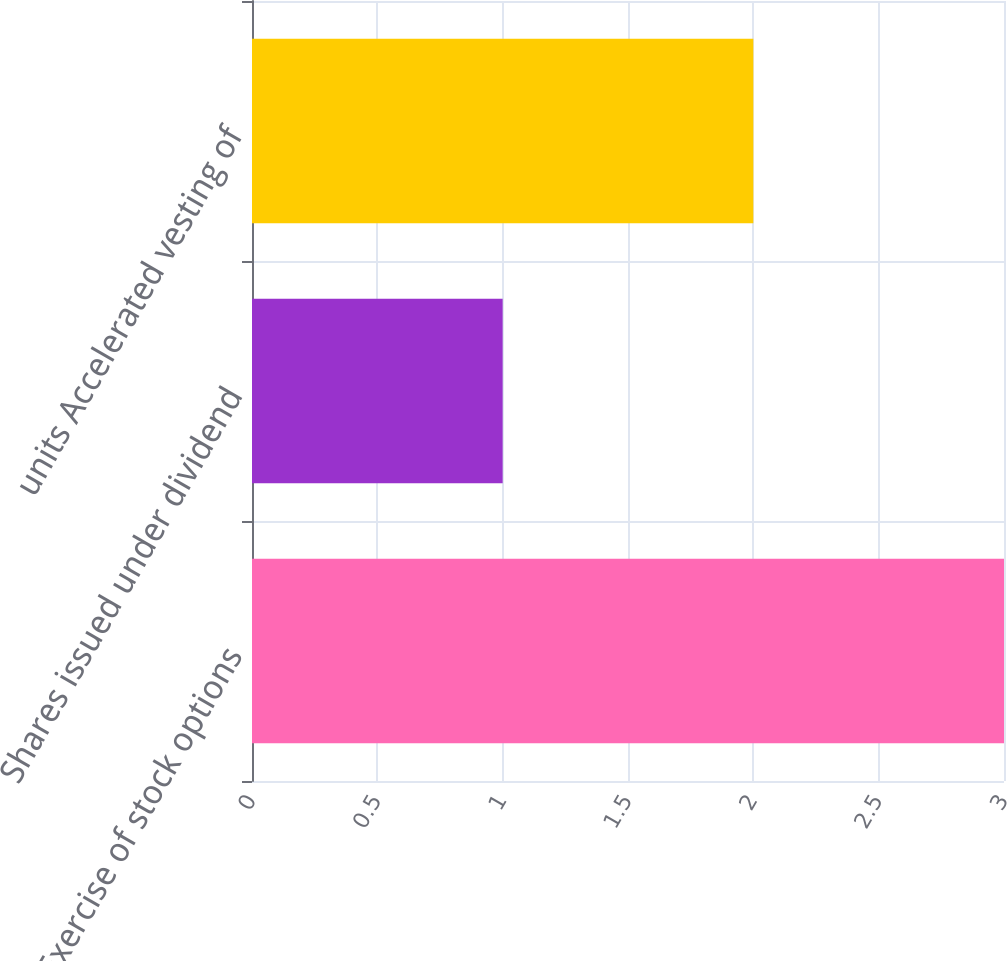Convert chart to OTSL. <chart><loc_0><loc_0><loc_500><loc_500><bar_chart><fcel>Exercise of stock options<fcel>Shares issued under dividend<fcel>units Accelerated vesting of<nl><fcel>3<fcel>1<fcel>2<nl></chart> 